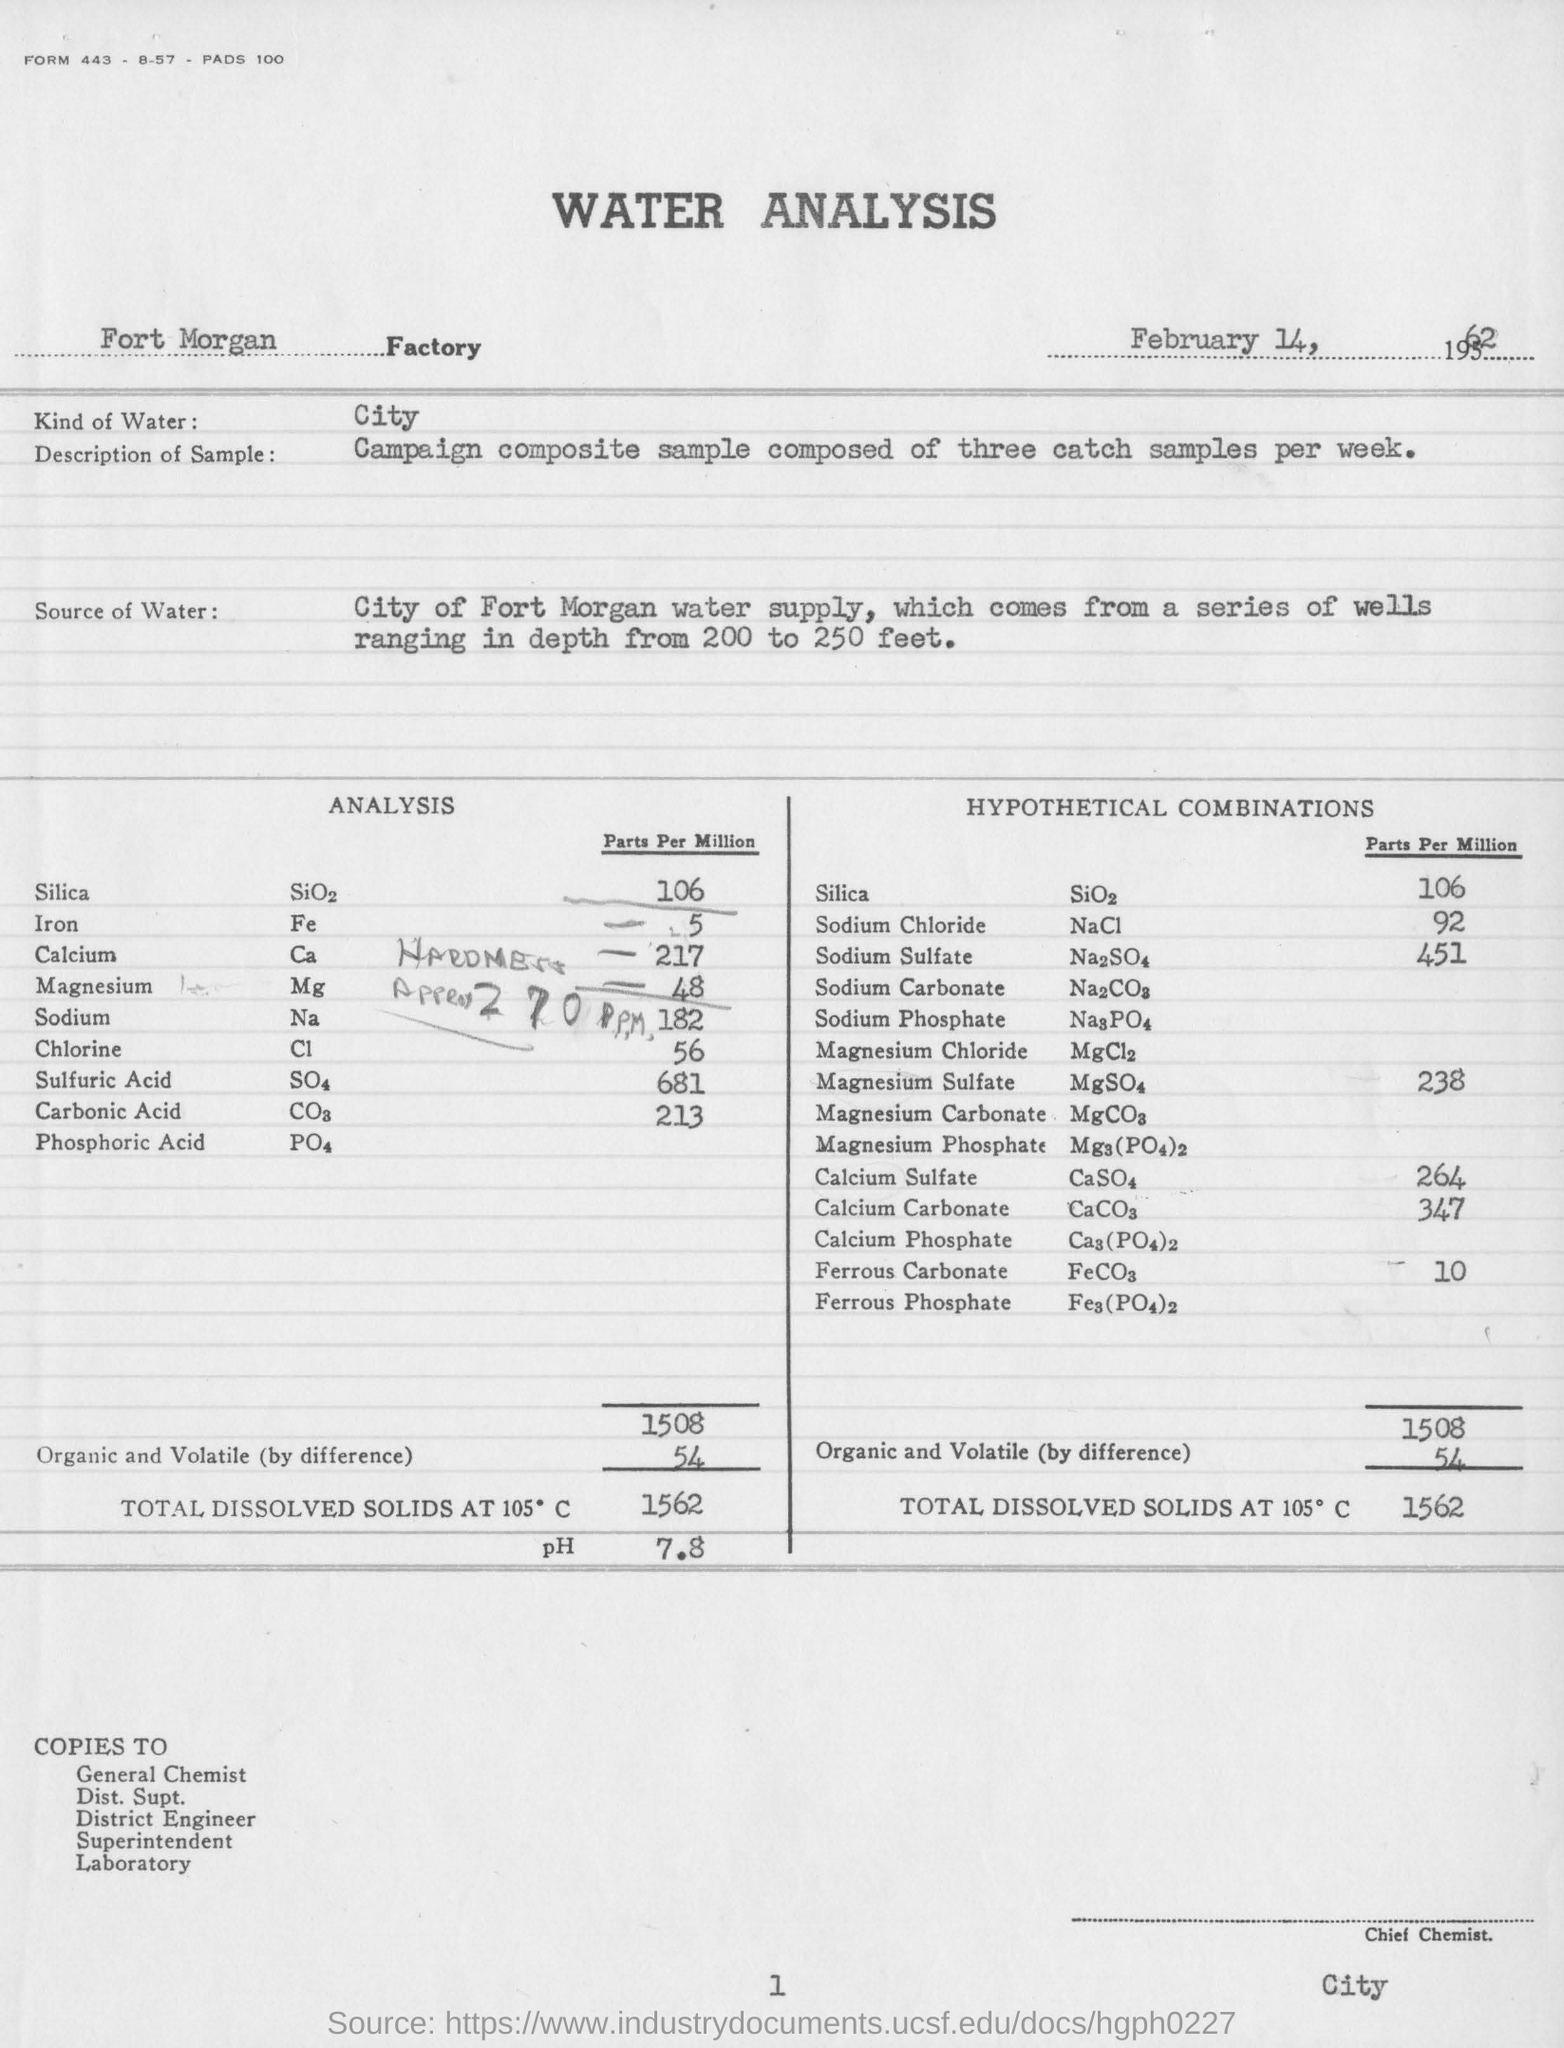Indicate a few pertinent items in this graphic. The pH value obtained in the water analysis was 7.8. The parts per million value of sodium chloride in hypothetical combinations is 92%. Water analysis is conducted using various types of water, including tap water, bottled water, and laboratory-grade water. The specific type of water used depends on the nature of the analysis and the requirements of the test method. In general, tap water is commonly used for routine analysis, while bottled water is used when higher levels of purity and quality are required. Laboratory-grade water is used for more specialized analyses that require ultra-high levels of purity and accuracy. The amount of total dissolved solids at 105 degrees Celsius is ? The Fort Morgan factory is the name of the factory. 